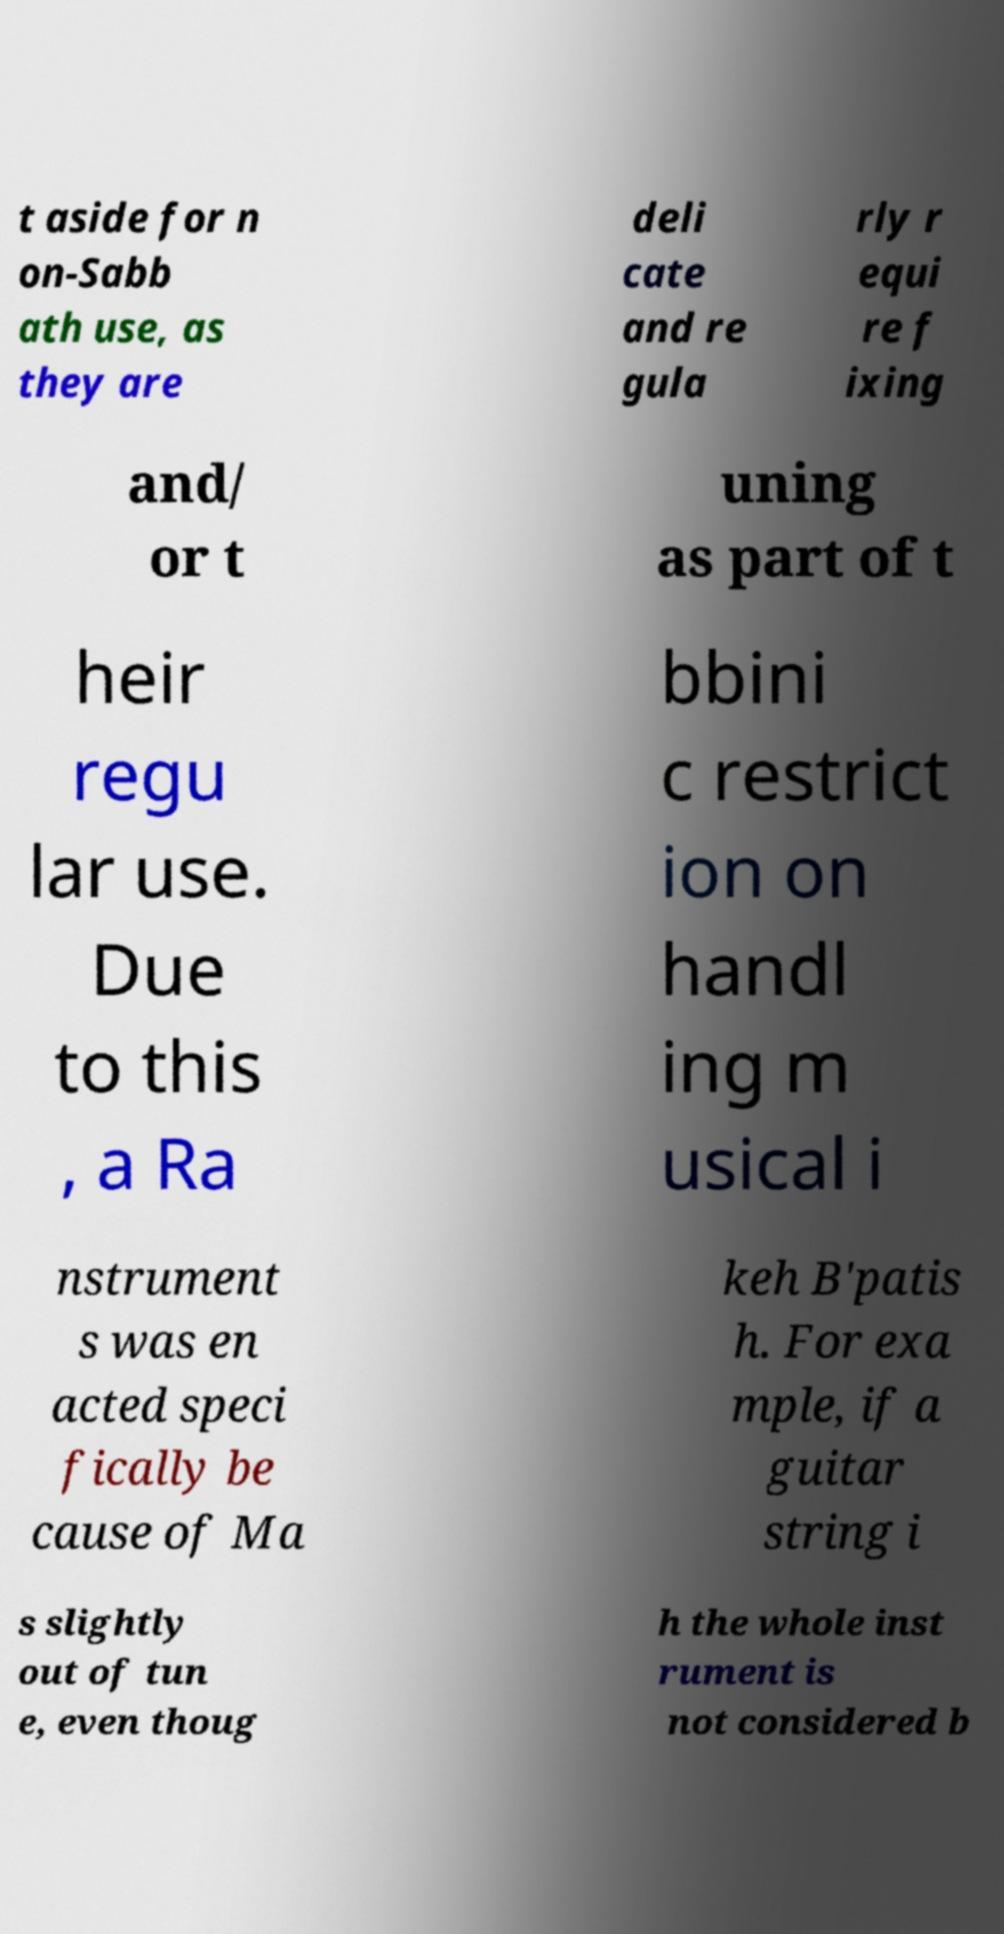Please read and relay the text visible in this image. What does it say? t aside for n on-Sabb ath use, as they are deli cate and re gula rly r equi re f ixing and/ or t uning as part of t heir regu lar use. Due to this , a Ra bbini c restrict ion on handl ing m usical i nstrument s was en acted speci fically be cause of Ma keh B'patis h. For exa mple, if a guitar string i s slightly out of tun e, even thoug h the whole inst rument is not considered b 